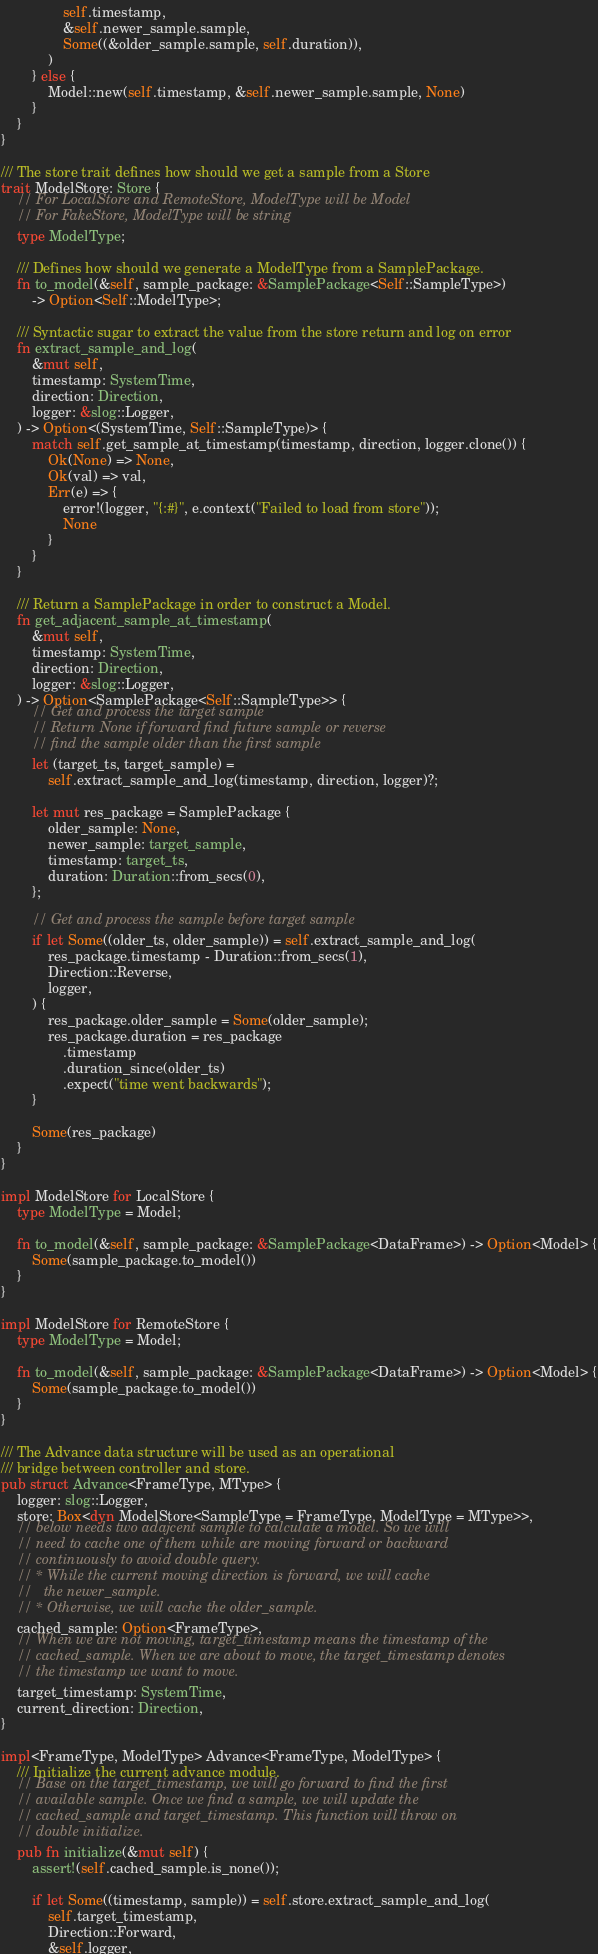<code> <loc_0><loc_0><loc_500><loc_500><_Rust_>                self.timestamp,
                &self.newer_sample.sample,
                Some((&older_sample.sample, self.duration)),
            )
        } else {
            Model::new(self.timestamp, &self.newer_sample.sample, None)
        }
    }
}

/// The store trait defines how should we get a sample from a Store
trait ModelStore: Store {
    // For LocalStore and RemoteStore, ModelType will be Model
    // For FakeStore, ModelType will be string
    type ModelType;

    /// Defines how should we generate a ModelType from a SamplePackage.
    fn to_model(&self, sample_package: &SamplePackage<Self::SampleType>)
        -> Option<Self::ModelType>;

    /// Syntactic sugar to extract the value from the store return and log on error
    fn extract_sample_and_log(
        &mut self,
        timestamp: SystemTime,
        direction: Direction,
        logger: &slog::Logger,
    ) -> Option<(SystemTime, Self::SampleType)> {
        match self.get_sample_at_timestamp(timestamp, direction, logger.clone()) {
            Ok(None) => None,
            Ok(val) => val,
            Err(e) => {
                error!(logger, "{:#}", e.context("Failed to load from store"));
                None
            }
        }
    }

    /// Return a SamplePackage in order to construct a Model.
    fn get_adjacent_sample_at_timestamp(
        &mut self,
        timestamp: SystemTime,
        direction: Direction,
        logger: &slog::Logger,
    ) -> Option<SamplePackage<Self::SampleType>> {
        // Get and process the target sample
        // Return None if forward find future sample or reverse
        // find the sample older than the first sample
        let (target_ts, target_sample) =
            self.extract_sample_and_log(timestamp, direction, logger)?;

        let mut res_package = SamplePackage {
            older_sample: None,
            newer_sample: target_sample,
            timestamp: target_ts,
            duration: Duration::from_secs(0),
        };

        // Get and process the sample before target sample
        if let Some((older_ts, older_sample)) = self.extract_sample_and_log(
            res_package.timestamp - Duration::from_secs(1),
            Direction::Reverse,
            logger,
        ) {
            res_package.older_sample = Some(older_sample);
            res_package.duration = res_package
                .timestamp
                .duration_since(older_ts)
                .expect("time went backwards");
        }

        Some(res_package)
    }
}

impl ModelStore for LocalStore {
    type ModelType = Model;

    fn to_model(&self, sample_package: &SamplePackage<DataFrame>) -> Option<Model> {
        Some(sample_package.to_model())
    }
}

impl ModelStore for RemoteStore {
    type ModelType = Model;

    fn to_model(&self, sample_package: &SamplePackage<DataFrame>) -> Option<Model> {
        Some(sample_package.to_model())
    }
}

/// The Advance data structure will be used as an operational
/// bridge between controller and store.
pub struct Advance<FrameType, MType> {
    logger: slog::Logger,
    store: Box<dyn ModelStore<SampleType = FrameType, ModelType = MType>>,
    // below needs two adajcent sample to calculate a model. So we will
    // need to cache one of them while are moving forward or backward
    // continuously to avoid double query.
    // * While the current moving direction is forward, we will cache
    //   the newer_sample.
    // * Otherwise, we will cache the older_sample.
    cached_sample: Option<FrameType>,
    // When we are not moving, target_timestamp means the timestamp of the
    // cached_sample. When we are about to move, the target_timestamp denotes
    // the timestamp we want to move.
    target_timestamp: SystemTime,
    current_direction: Direction,
}

impl<FrameType, ModelType> Advance<FrameType, ModelType> {
    /// Initialize the current advance module.
    // Base on the target_timestamp, we will go forward to find the first
    // available sample. Once we find a sample, we will update the
    // cached_sample and target_timestamp. This function will throw on
    // double initialize.
    pub fn initialize(&mut self) {
        assert!(self.cached_sample.is_none());

        if let Some((timestamp, sample)) = self.store.extract_sample_and_log(
            self.target_timestamp,
            Direction::Forward,
            &self.logger,</code> 